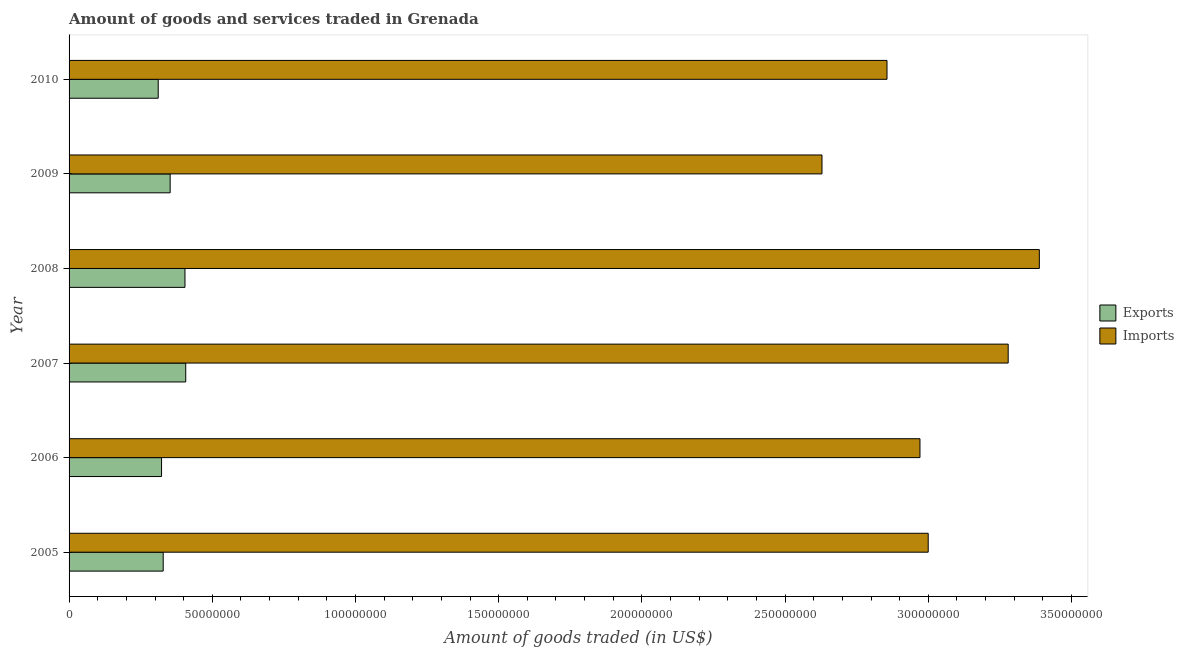How many different coloured bars are there?
Your response must be concise. 2. How many groups of bars are there?
Your answer should be very brief. 6. Are the number of bars on each tick of the Y-axis equal?
Give a very brief answer. Yes. How many bars are there on the 4th tick from the top?
Make the answer very short. 2. What is the label of the 1st group of bars from the top?
Offer a very short reply. 2010. In how many cases, is the number of bars for a given year not equal to the number of legend labels?
Offer a very short reply. 0. What is the amount of goods exported in 2007?
Offer a terse response. 4.07e+07. Across all years, what is the maximum amount of goods imported?
Your response must be concise. 3.39e+08. Across all years, what is the minimum amount of goods imported?
Make the answer very short. 2.63e+08. In which year was the amount of goods exported maximum?
Your answer should be compact. 2007. In which year was the amount of goods imported minimum?
Make the answer very short. 2009. What is the total amount of goods imported in the graph?
Provide a succinct answer. 1.81e+09. What is the difference between the amount of goods exported in 2005 and that in 2009?
Offer a very short reply. -2.43e+06. What is the difference between the amount of goods exported in 2008 and the amount of goods imported in 2007?
Provide a succinct answer. -2.87e+08. What is the average amount of goods exported per year?
Offer a terse response. 3.55e+07. In the year 2010, what is the difference between the amount of goods exported and amount of goods imported?
Offer a terse response. -2.54e+08. In how many years, is the amount of goods imported greater than 90000000 US$?
Provide a short and direct response. 6. What is the ratio of the amount of goods exported in 2006 to that in 2008?
Your answer should be very brief. 0.8. Is the amount of goods exported in 2006 less than that in 2008?
Keep it short and to the point. Yes. What is the difference between the highest and the second highest amount of goods imported?
Ensure brevity in your answer.  1.09e+07. What is the difference between the highest and the lowest amount of goods imported?
Give a very brief answer. 7.59e+07. In how many years, is the amount of goods imported greater than the average amount of goods imported taken over all years?
Offer a very short reply. 2. Is the sum of the amount of goods exported in 2009 and 2010 greater than the maximum amount of goods imported across all years?
Give a very brief answer. No. What does the 1st bar from the top in 2007 represents?
Make the answer very short. Imports. What does the 1st bar from the bottom in 2006 represents?
Your response must be concise. Exports. Are all the bars in the graph horizontal?
Your answer should be compact. Yes. How many years are there in the graph?
Keep it short and to the point. 6. What is the difference between two consecutive major ticks on the X-axis?
Give a very brief answer. 5.00e+07. Does the graph contain any zero values?
Your response must be concise. No. How many legend labels are there?
Offer a very short reply. 2. How are the legend labels stacked?
Provide a succinct answer. Vertical. What is the title of the graph?
Make the answer very short. Amount of goods and services traded in Grenada. What is the label or title of the X-axis?
Provide a short and direct response. Amount of goods traded (in US$). What is the Amount of goods traded (in US$) of Exports in 2005?
Keep it short and to the point. 3.29e+07. What is the Amount of goods traded (in US$) in Imports in 2005?
Offer a terse response. 3.00e+08. What is the Amount of goods traded (in US$) of Exports in 2006?
Provide a succinct answer. 3.23e+07. What is the Amount of goods traded (in US$) of Imports in 2006?
Offer a terse response. 2.97e+08. What is the Amount of goods traded (in US$) in Exports in 2007?
Give a very brief answer. 4.07e+07. What is the Amount of goods traded (in US$) of Imports in 2007?
Offer a very short reply. 3.28e+08. What is the Amount of goods traded (in US$) of Exports in 2008?
Offer a very short reply. 4.05e+07. What is the Amount of goods traded (in US$) of Imports in 2008?
Your answer should be very brief. 3.39e+08. What is the Amount of goods traded (in US$) of Exports in 2009?
Your answer should be compact. 3.53e+07. What is the Amount of goods traded (in US$) in Imports in 2009?
Offer a terse response. 2.63e+08. What is the Amount of goods traded (in US$) in Exports in 2010?
Provide a short and direct response. 3.11e+07. What is the Amount of goods traded (in US$) of Imports in 2010?
Provide a short and direct response. 2.86e+08. Across all years, what is the maximum Amount of goods traded (in US$) of Exports?
Make the answer very short. 4.07e+07. Across all years, what is the maximum Amount of goods traded (in US$) in Imports?
Offer a terse response. 3.39e+08. Across all years, what is the minimum Amount of goods traded (in US$) of Exports?
Offer a very short reply. 3.11e+07. Across all years, what is the minimum Amount of goods traded (in US$) of Imports?
Give a very brief answer. 2.63e+08. What is the total Amount of goods traded (in US$) in Exports in the graph?
Your answer should be compact. 2.13e+08. What is the total Amount of goods traded (in US$) in Imports in the graph?
Offer a terse response. 1.81e+09. What is the difference between the Amount of goods traded (in US$) in Exports in 2005 and that in 2006?
Give a very brief answer. 5.80e+05. What is the difference between the Amount of goods traded (in US$) of Imports in 2005 and that in 2006?
Keep it short and to the point. 2.88e+06. What is the difference between the Amount of goods traded (in US$) of Exports in 2005 and that in 2007?
Provide a succinct answer. -7.87e+06. What is the difference between the Amount of goods traded (in US$) in Imports in 2005 and that in 2007?
Provide a succinct answer. -2.79e+07. What is the difference between the Amount of goods traded (in US$) in Exports in 2005 and that in 2008?
Provide a succinct answer. -7.60e+06. What is the difference between the Amount of goods traded (in US$) in Imports in 2005 and that in 2008?
Provide a succinct answer. -3.88e+07. What is the difference between the Amount of goods traded (in US$) in Exports in 2005 and that in 2009?
Keep it short and to the point. -2.43e+06. What is the difference between the Amount of goods traded (in US$) of Imports in 2005 and that in 2009?
Make the answer very short. 3.71e+07. What is the difference between the Amount of goods traded (in US$) in Exports in 2005 and that in 2010?
Your response must be concise. 1.74e+06. What is the difference between the Amount of goods traded (in US$) in Imports in 2005 and that in 2010?
Give a very brief answer. 1.44e+07. What is the difference between the Amount of goods traded (in US$) in Exports in 2006 and that in 2007?
Offer a very short reply. -8.45e+06. What is the difference between the Amount of goods traded (in US$) in Imports in 2006 and that in 2007?
Offer a very short reply. -3.08e+07. What is the difference between the Amount of goods traded (in US$) of Exports in 2006 and that in 2008?
Ensure brevity in your answer.  -8.18e+06. What is the difference between the Amount of goods traded (in US$) in Imports in 2006 and that in 2008?
Ensure brevity in your answer.  -4.17e+07. What is the difference between the Amount of goods traded (in US$) in Exports in 2006 and that in 2009?
Provide a succinct answer. -3.01e+06. What is the difference between the Amount of goods traded (in US$) in Imports in 2006 and that in 2009?
Give a very brief answer. 3.42e+07. What is the difference between the Amount of goods traded (in US$) in Exports in 2006 and that in 2010?
Ensure brevity in your answer.  1.16e+06. What is the difference between the Amount of goods traded (in US$) in Imports in 2006 and that in 2010?
Offer a terse response. 1.15e+07. What is the difference between the Amount of goods traded (in US$) of Exports in 2007 and that in 2008?
Give a very brief answer. 2.65e+05. What is the difference between the Amount of goods traded (in US$) in Imports in 2007 and that in 2008?
Provide a short and direct response. -1.09e+07. What is the difference between the Amount of goods traded (in US$) of Exports in 2007 and that in 2009?
Provide a short and direct response. 5.44e+06. What is the difference between the Amount of goods traded (in US$) of Imports in 2007 and that in 2009?
Your response must be concise. 6.50e+07. What is the difference between the Amount of goods traded (in US$) of Exports in 2007 and that in 2010?
Your answer should be very brief. 9.61e+06. What is the difference between the Amount of goods traded (in US$) in Imports in 2007 and that in 2010?
Provide a succinct answer. 4.23e+07. What is the difference between the Amount of goods traded (in US$) of Exports in 2008 and that in 2009?
Keep it short and to the point. 5.17e+06. What is the difference between the Amount of goods traded (in US$) in Imports in 2008 and that in 2009?
Offer a very short reply. 7.59e+07. What is the difference between the Amount of goods traded (in US$) in Exports in 2008 and that in 2010?
Give a very brief answer. 9.34e+06. What is the difference between the Amount of goods traded (in US$) of Imports in 2008 and that in 2010?
Your answer should be compact. 5.32e+07. What is the difference between the Amount of goods traded (in US$) in Exports in 2009 and that in 2010?
Your answer should be compact. 4.17e+06. What is the difference between the Amount of goods traded (in US$) of Imports in 2009 and that in 2010?
Your answer should be compact. -2.27e+07. What is the difference between the Amount of goods traded (in US$) in Exports in 2005 and the Amount of goods traded (in US$) in Imports in 2006?
Your answer should be very brief. -2.64e+08. What is the difference between the Amount of goods traded (in US$) of Exports in 2005 and the Amount of goods traded (in US$) of Imports in 2007?
Provide a succinct answer. -2.95e+08. What is the difference between the Amount of goods traded (in US$) of Exports in 2005 and the Amount of goods traded (in US$) of Imports in 2008?
Your answer should be compact. -3.06e+08. What is the difference between the Amount of goods traded (in US$) of Exports in 2005 and the Amount of goods traded (in US$) of Imports in 2009?
Offer a very short reply. -2.30e+08. What is the difference between the Amount of goods traded (in US$) of Exports in 2005 and the Amount of goods traded (in US$) of Imports in 2010?
Give a very brief answer. -2.53e+08. What is the difference between the Amount of goods traded (in US$) of Exports in 2006 and the Amount of goods traded (in US$) of Imports in 2007?
Keep it short and to the point. -2.96e+08. What is the difference between the Amount of goods traded (in US$) of Exports in 2006 and the Amount of goods traded (in US$) of Imports in 2008?
Your response must be concise. -3.06e+08. What is the difference between the Amount of goods traded (in US$) in Exports in 2006 and the Amount of goods traded (in US$) in Imports in 2009?
Make the answer very short. -2.31e+08. What is the difference between the Amount of goods traded (in US$) in Exports in 2006 and the Amount of goods traded (in US$) in Imports in 2010?
Give a very brief answer. -2.53e+08. What is the difference between the Amount of goods traded (in US$) in Exports in 2007 and the Amount of goods traded (in US$) in Imports in 2008?
Offer a terse response. -2.98e+08. What is the difference between the Amount of goods traded (in US$) of Exports in 2007 and the Amount of goods traded (in US$) of Imports in 2009?
Give a very brief answer. -2.22e+08. What is the difference between the Amount of goods traded (in US$) of Exports in 2007 and the Amount of goods traded (in US$) of Imports in 2010?
Your response must be concise. -2.45e+08. What is the difference between the Amount of goods traded (in US$) in Exports in 2008 and the Amount of goods traded (in US$) in Imports in 2009?
Keep it short and to the point. -2.22e+08. What is the difference between the Amount of goods traded (in US$) of Exports in 2008 and the Amount of goods traded (in US$) of Imports in 2010?
Your answer should be compact. -2.45e+08. What is the difference between the Amount of goods traded (in US$) in Exports in 2009 and the Amount of goods traded (in US$) in Imports in 2010?
Provide a short and direct response. -2.50e+08. What is the average Amount of goods traded (in US$) in Exports per year?
Offer a very short reply. 3.55e+07. What is the average Amount of goods traded (in US$) of Imports per year?
Provide a short and direct response. 3.02e+08. In the year 2005, what is the difference between the Amount of goods traded (in US$) in Exports and Amount of goods traded (in US$) in Imports?
Keep it short and to the point. -2.67e+08. In the year 2006, what is the difference between the Amount of goods traded (in US$) in Exports and Amount of goods traded (in US$) in Imports?
Provide a succinct answer. -2.65e+08. In the year 2007, what is the difference between the Amount of goods traded (in US$) of Exports and Amount of goods traded (in US$) of Imports?
Provide a short and direct response. -2.87e+08. In the year 2008, what is the difference between the Amount of goods traded (in US$) in Exports and Amount of goods traded (in US$) in Imports?
Offer a very short reply. -2.98e+08. In the year 2009, what is the difference between the Amount of goods traded (in US$) of Exports and Amount of goods traded (in US$) of Imports?
Your answer should be very brief. -2.28e+08. In the year 2010, what is the difference between the Amount of goods traded (in US$) of Exports and Amount of goods traded (in US$) of Imports?
Your response must be concise. -2.54e+08. What is the ratio of the Amount of goods traded (in US$) of Exports in 2005 to that in 2006?
Your answer should be very brief. 1.02. What is the ratio of the Amount of goods traded (in US$) in Imports in 2005 to that in 2006?
Ensure brevity in your answer.  1.01. What is the ratio of the Amount of goods traded (in US$) in Exports in 2005 to that in 2007?
Ensure brevity in your answer.  0.81. What is the ratio of the Amount of goods traded (in US$) of Imports in 2005 to that in 2007?
Give a very brief answer. 0.91. What is the ratio of the Amount of goods traded (in US$) of Exports in 2005 to that in 2008?
Your response must be concise. 0.81. What is the ratio of the Amount of goods traded (in US$) of Imports in 2005 to that in 2008?
Keep it short and to the point. 0.89. What is the ratio of the Amount of goods traded (in US$) of Exports in 2005 to that in 2009?
Your answer should be very brief. 0.93. What is the ratio of the Amount of goods traded (in US$) in Imports in 2005 to that in 2009?
Give a very brief answer. 1.14. What is the ratio of the Amount of goods traded (in US$) in Exports in 2005 to that in 2010?
Provide a succinct answer. 1.06. What is the ratio of the Amount of goods traded (in US$) of Imports in 2005 to that in 2010?
Your response must be concise. 1.05. What is the ratio of the Amount of goods traded (in US$) in Exports in 2006 to that in 2007?
Ensure brevity in your answer.  0.79. What is the ratio of the Amount of goods traded (in US$) in Imports in 2006 to that in 2007?
Keep it short and to the point. 0.91. What is the ratio of the Amount of goods traded (in US$) in Exports in 2006 to that in 2008?
Provide a short and direct response. 0.8. What is the ratio of the Amount of goods traded (in US$) of Imports in 2006 to that in 2008?
Offer a terse response. 0.88. What is the ratio of the Amount of goods traded (in US$) in Exports in 2006 to that in 2009?
Provide a succinct answer. 0.91. What is the ratio of the Amount of goods traded (in US$) in Imports in 2006 to that in 2009?
Offer a terse response. 1.13. What is the ratio of the Amount of goods traded (in US$) in Exports in 2006 to that in 2010?
Keep it short and to the point. 1.04. What is the ratio of the Amount of goods traded (in US$) in Imports in 2006 to that in 2010?
Your response must be concise. 1.04. What is the ratio of the Amount of goods traded (in US$) in Exports in 2007 to that in 2008?
Your answer should be compact. 1.01. What is the ratio of the Amount of goods traded (in US$) in Imports in 2007 to that in 2008?
Ensure brevity in your answer.  0.97. What is the ratio of the Amount of goods traded (in US$) of Exports in 2007 to that in 2009?
Your response must be concise. 1.15. What is the ratio of the Amount of goods traded (in US$) of Imports in 2007 to that in 2009?
Offer a very short reply. 1.25. What is the ratio of the Amount of goods traded (in US$) of Exports in 2007 to that in 2010?
Your response must be concise. 1.31. What is the ratio of the Amount of goods traded (in US$) in Imports in 2007 to that in 2010?
Offer a very short reply. 1.15. What is the ratio of the Amount of goods traded (in US$) in Exports in 2008 to that in 2009?
Your answer should be compact. 1.15. What is the ratio of the Amount of goods traded (in US$) of Imports in 2008 to that in 2009?
Ensure brevity in your answer.  1.29. What is the ratio of the Amount of goods traded (in US$) of Exports in 2008 to that in 2010?
Offer a very short reply. 1.3. What is the ratio of the Amount of goods traded (in US$) in Imports in 2008 to that in 2010?
Ensure brevity in your answer.  1.19. What is the ratio of the Amount of goods traded (in US$) in Exports in 2009 to that in 2010?
Your answer should be very brief. 1.13. What is the ratio of the Amount of goods traded (in US$) of Imports in 2009 to that in 2010?
Offer a terse response. 0.92. What is the difference between the highest and the second highest Amount of goods traded (in US$) in Exports?
Offer a terse response. 2.65e+05. What is the difference between the highest and the second highest Amount of goods traded (in US$) in Imports?
Ensure brevity in your answer.  1.09e+07. What is the difference between the highest and the lowest Amount of goods traded (in US$) in Exports?
Offer a very short reply. 9.61e+06. What is the difference between the highest and the lowest Amount of goods traded (in US$) in Imports?
Offer a terse response. 7.59e+07. 